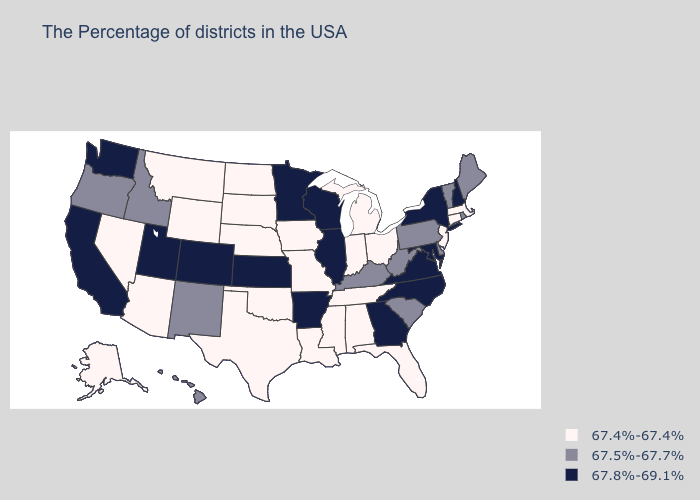Does New Mexico have the lowest value in the USA?
Keep it brief. No. Which states have the lowest value in the USA?
Be succinct. Massachusetts, Connecticut, New Jersey, Ohio, Florida, Michigan, Indiana, Alabama, Tennessee, Mississippi, Louisiana, Missouri, Iowa, Nebraska, Oklahoma, Texas, South Dakota, North Dakota, Wyoming, Montana, Arizona, Nevada, Alaska. Name the states that have a value in the range 67.5%-67.7%?
Answer briefly. Maine, Rhode Island, Vermont, Delaware, Pennsylvania, South Carolina, West Virginia, Kentucky, New Mexico, Idaho, Oregon, Hawaii. What is the lowest value in the South?
Short answer required. 67.4%-67.4%. Name the states that have a value in the range 67.8%-69.1%?
Keep it brief. New Hampshire, New York, Maryland, Virginia, North Carolina, Georgia, Wisconsin, Illinois, Arkansas, Minnesota, Kansas, Colorado, Utah, California, Washington. Does Massachusetts have the lowest value in the USA?
Keep it brief. Yes. Does North Dakota have a higher value than Tennessee?
Answer briefly. No. What is the value of Nevada?
Be succinct. 67.4%-67.4%. What is the value of Connecticut?
Short answer required. 67.4%-67.4%. Which states have the highest value in the USA?
Short answer required. New Hampshire, New York, Maryland, Virginia, North Carolina, Georgia, Wisconsin, Illinois, Arkansas, Minnesota, Kansas, Colorado, Utah, California, Washington. What is the value of North Carolina?
Give a very brief answer. 67.8%-69.1%. Does Delaware have a lower value than Connecticut?
Concise answer only. No. Among the states that border Oklahoma , does Texas have the lowest value?
Write a very short answer. Yes. Name the states that have a value in the range 67.4%-67.4%?
Answer briefly. Massachusetts, Connecticut, New Jersey, Ohio, Florida, Michigan, Indiana, Alabama, Tennessee, Mississippi, Louisiana, Missouri, Iowa, Nebraska, Oklahoma, Texas, South Dakota, North Dakota, Wyoming, Montana, Arizona, Nevada, Alaska. What is the value of Indiana?
Give a very brief answer. 67.4%-67.4%. 